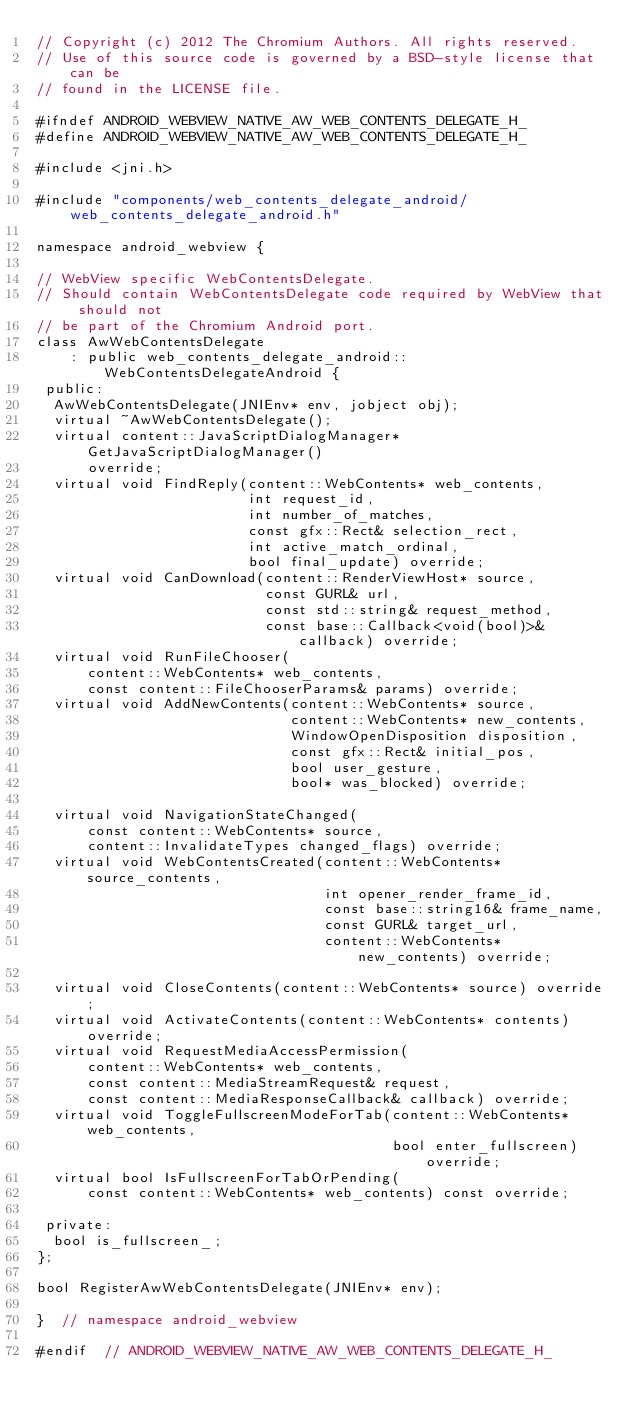<code> <loc_0><loc_0><loc_500><loc_500><_C_>// Copyright (c) 2012 The Chromium Authors. All rights reserved.
// Use of this source code is governed by a BSD-style license that can be
// found in the LICENSE file.

#ifndef ANDROID_WEBVIEW_NATIVE_AW_WEB_CONTENTS_DELEGATE_H_
#define ANDROID_WEBVIEW_NATIVE_AW_WEB_CONTENTS_DELEGATE_H_

#include <jni.h>

#include "components/web_contents_delegate_android/web_contents_delegate_android.h"

namespace android_webview {

// WebView specific WebContentsDelegate.
// Should contain WebContentsDelegate code required by WebView that should not
// be part of the Chromium Android port.
class AwWebContentsDelegate
    : public web_contents_delegate_android::WebContentsDelegateAndroid {
 public:
  AwWebContentsDelegate(JNIEnv* env, jobject obj);
  virtual ~AwWebContentsDelegate();
  virtual content::JavaScriptDialogManager* GetJavaScriptDialogManager()
      override;
  virtual void FindReply(content::WebContents* web_contents,
                         int request_id,
                         int number_of_matches,
                         const gfx::Rect& selection_rect,
                         int active_match_ordinal,
                         bool final_update) override;
  virtual void CanDownload(content::RenderViewHost* source,
                           const GURL& url,
                           const std::string& request_method,
                           const base::Callback<void(bool)>& callback) override;
  virtual void RunFileChooser(
      content::WebContents* web_contents,
      const content::FileChooserParams& params) override;
  virtual void AddNewContents(content::WebContents* source,
                              content::WebContents* new_contents,
                              WindowOpenDisposition disposition,
                              const gfx::Rect& initial_pos,
                              bool user_gesture,
                              bool* was_blocked) override;

  virtual void NavigationStateChanged(
      const content::WebContents* source,
      content::InvalidateTypes changed_flags) override;
  virtual void WebContentsCreated(content::WebContents* source_contents,
                                  int opener_render_frame_id,
                                  const base::string16& frame_name,
                                  const GURL& target_url,
                                  content::WebContents* new_contents) override;

  virtual void CloseContents(content::WebContents* source) override;
  virtual void ActivateContents(content::WebContents* contents) override;
  virtual void RequestMediaAccessPermission(
      content::WebContents* web_contents,
      const content::MediaStreamRequest& request,
      const content::MediaResponseCallback& callback) override;
  virtual void ToggleFullscreenModeForTab(content::WebContents* web_contents,
                                          bool enter_fullscreen) override;
  virtual bool IsFullscreenForTabOrPending(
      const content::WebContents* web_contents) const override;

 private:
  bool is_fullscreen_;
};

bool RegisterAwWebContentsDelegate(JNIEnv* env);

}  // namespace android_webview

#endif  // ANDROID_WEBVIEW_NATIVE_AW_WEB_CONTENTS_DELEGATE_H_
</code> 